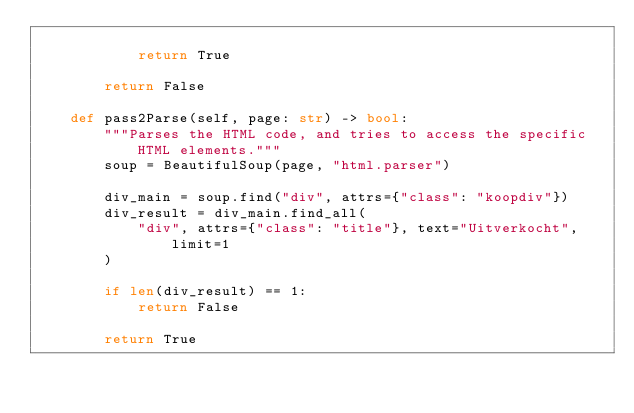Convert code to text. <code><loc_0><loc_0><loc_500><loc_500><_Python_>
            return True

        return False

    def pass2Parse(self, page: str) -> bool:
        """Parses the HTML code, and tries to access the specific HTML elements."""
        soup = BeautifulSoup(page, "html.parser")

        div_main = soup.find("div", attrs={"class": "koopdiv"})
        div_result = div_main.find_all(
            "div", attrs={"class": "title"}, text="Uitverkocht", limit=1
        )

        if len(div_result) == 1:
            return False

        return True
</code> 